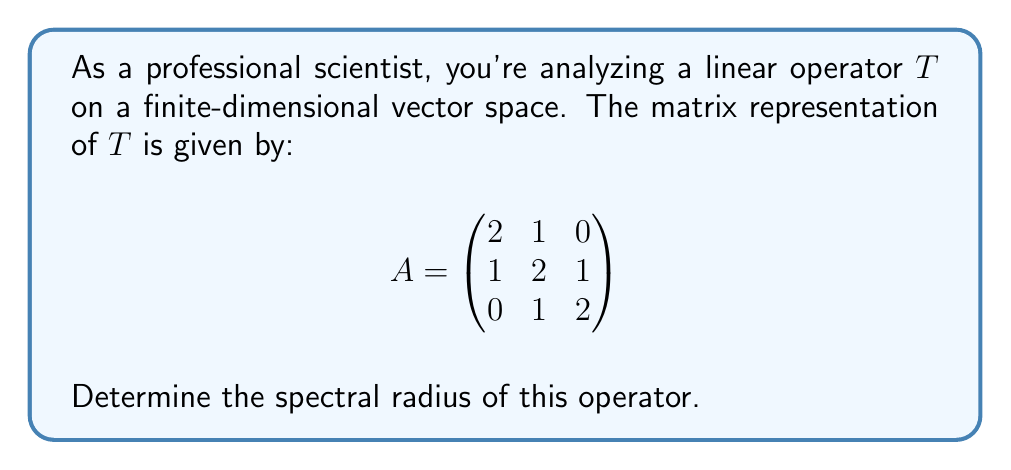Provide a solution to this math problem. To find the spectral radius of the linear operator $T$, we need to follow these steps:

1) The spectral radius is defined as the maximum absolute value of the eigenvalues of the operator.

2) To find the eigenvalues, we need to solve the characteristic equation:
   $det(A - \lambda I) = 0$

3) Expand the determinant:
   $$\begin{vmatrix}
   2-\lambda & 1 & 0 \\
   1 & 2-\lambda & 1 \\
   0 & 1 & 2-\lambda
   \end{vmatrix} = 0$$

4) This gives us:
   $(2-\lambda)[(2-\lambda)^2 - 1] - 1(1-0) = 0$

5) Simplify:
   $(2-\lambda)[(2-\lambda)^2 - 1] - 1 = 0$
   $(2-\lambda)^3 - (2-\lambda) - 1 = 0$
   $\lambda^3 - 6\lambda^2 + 11\lambda - 6 = 0$

6) This cubic equation can be factored as:
   $(\lambda - 1)(\lambda - 2)(\lambda - 3) = 0$

7) The eigenvalues are therefore $\lambda_1 = 1$, $\lambda_2 = 2$, and $\lambda_3 = 3$

8) The spectral radius is the maximum absolute value of these eigenvalues:
   $\rho(T) = \max\{|1|, |2|, |3|\} = 3$
Answer: 3 